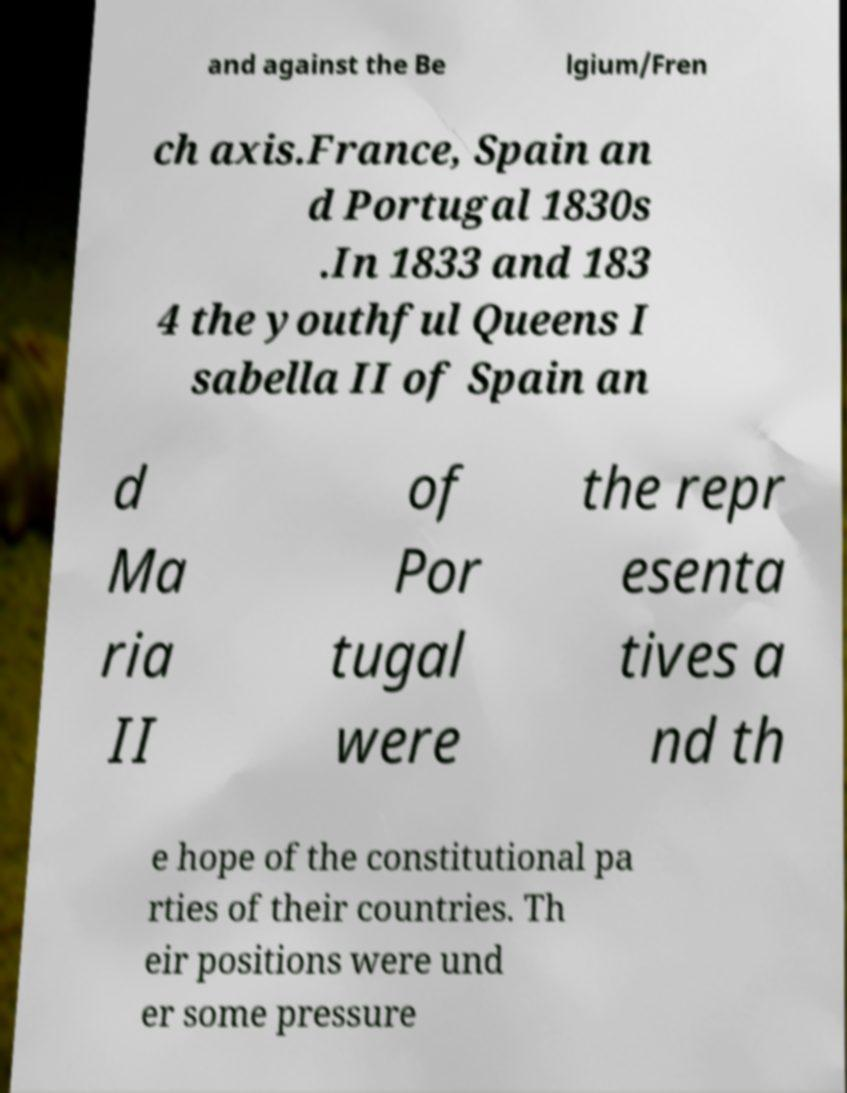For documentation purposes, I need the text within this image transcribed. Could you provide that? and against the Be lgium/Fren ch axis.France, Spain an d Portugal 1830s .In 1833 and 183 4 the youthful Queens I sabella II of Spain an d Ma ria II of Por tugal were the repr esenta tives a nd th e hope of the constitutional pa rties of their countries. Th eir positions were und er some pressure 